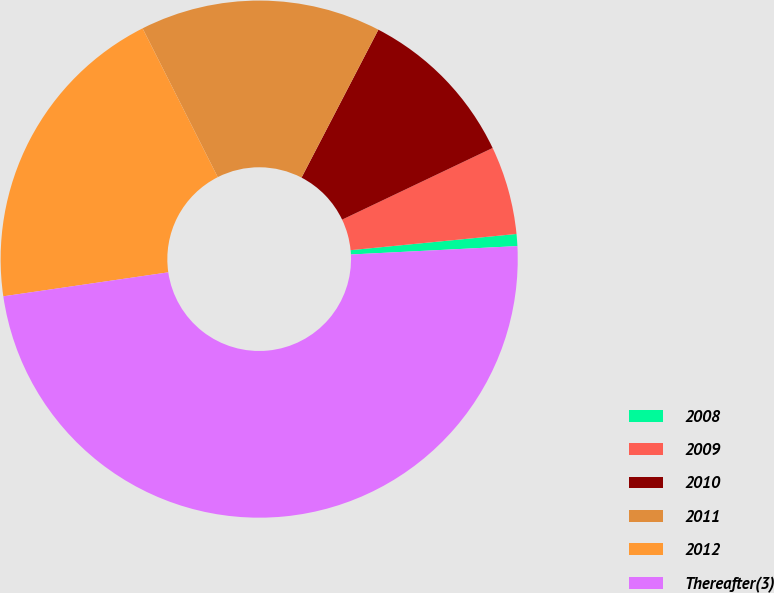<chart> <loc_0><loc_0><loc_500><loc_500><pie_chart><fcel>2008<fcel>2009<fcel>2010<fcel>2011<fcel>2012<fcel>Thereafter(3)<nl><fcel>0.75%<fcel>5.52%<fcel>10.3%<fcel>15.07%<fcel>19.85%<fcel>48.5%<nl></chart> 